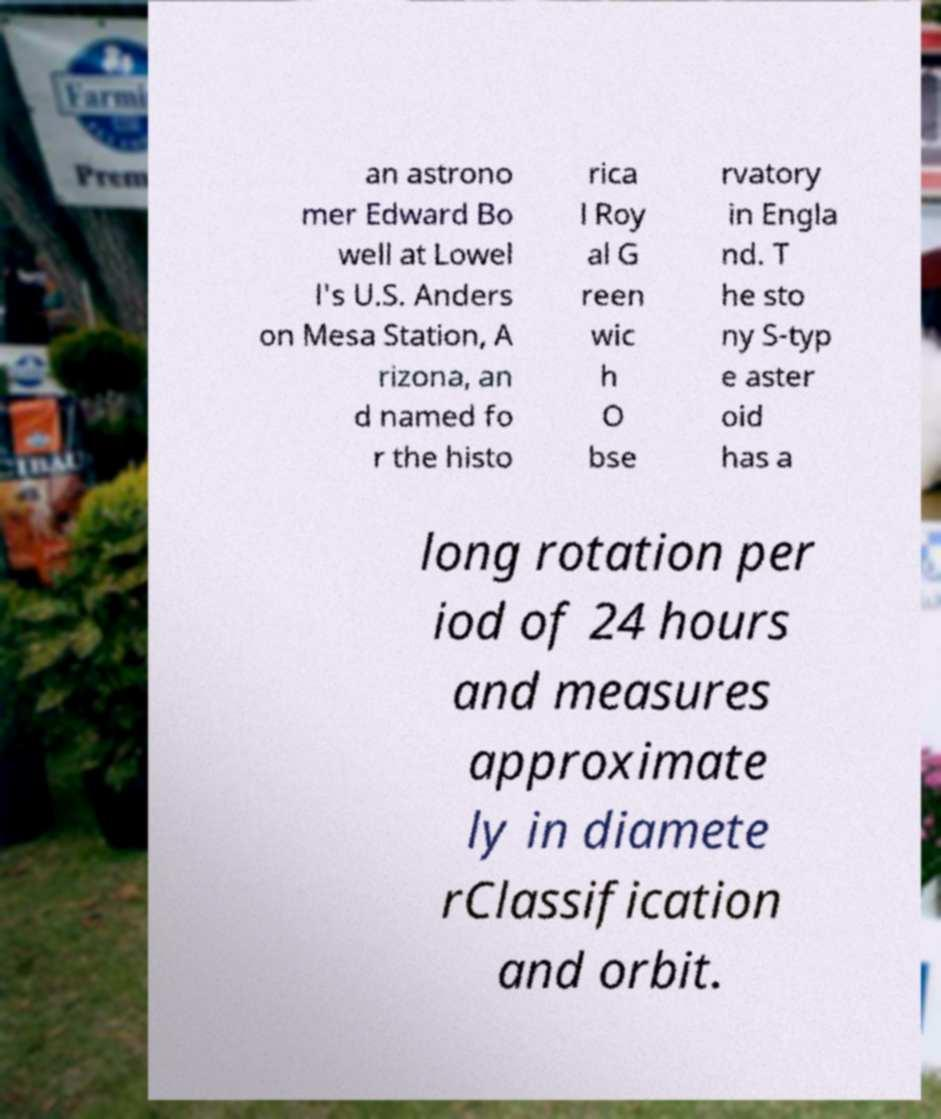Please read and relay the text visible in this image. What does it say? an astrono mer Edward Bo well at Lowel l's U.S. Anders on Mesa Station, A rizona, an d named fo r the histo rica l Roy al G reen wic h O bse rvatory in Engla nd. T he sto ny S-typ e aster oid has a long rotation per iod of 24 hours and measures approximate ly in diamete rClassification and orbit. 